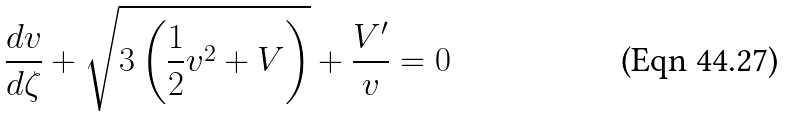<formula> <loc_0><loc_0><loc_500><loc_500>\frac { d v } { d \zeta } + \sqrt { 3 \left ( \frac { 1 } { 2 } v ^ { 2 } + V \right ) } + \frac { V ^ { \prime } } { v } = 0</formula> 